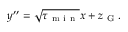<formula> <loc_0><loc_0><loc_500><loc_500>y ^ { \prime \prime } = \sqrt { \tau _ { m i n } } x + z _ { G } .</formula> 